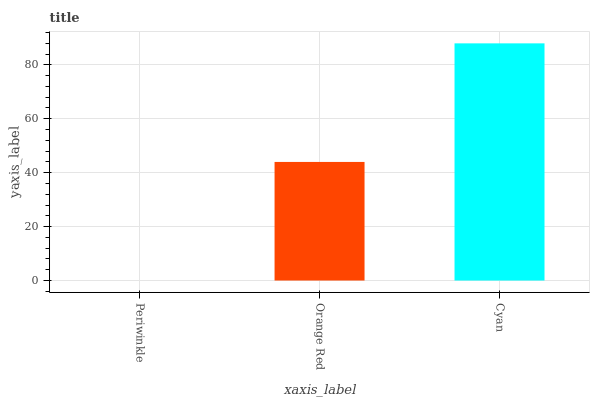Is Periwinkle the minimum?
Answer yes or no. Yes. Is Cyan the maximum?
Answer yes or no. Yes. Is Orange Red the minimum?
Answer yes or no. No. Is Orange Red the maximum?
Answer yes or no. No. Is Orange Red greater than Periwinkle?
Answer yes or no. Yes. Is Periwinkle less than Orange Red?
Answer yes or no. Yes. Is Periwinkle greater than Orange Red?
Answer yes or no. No. Is Orange Red less than Periwinkle?
Answer yes or no. No. Is Orange Red the high median?
Answer yes or no. Yes. Is Orange Red the low median?
Answer yes or no. Yes. Is Cyan the high median?
Answer yes or no. No. Is Cyan the low median?
Answer yes or no. No. 